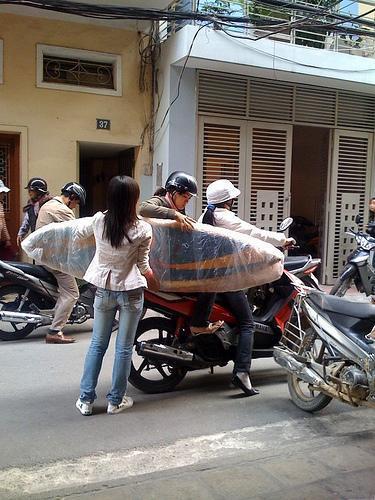How many motorcycles are there?
Give a very brief answer. 4. 